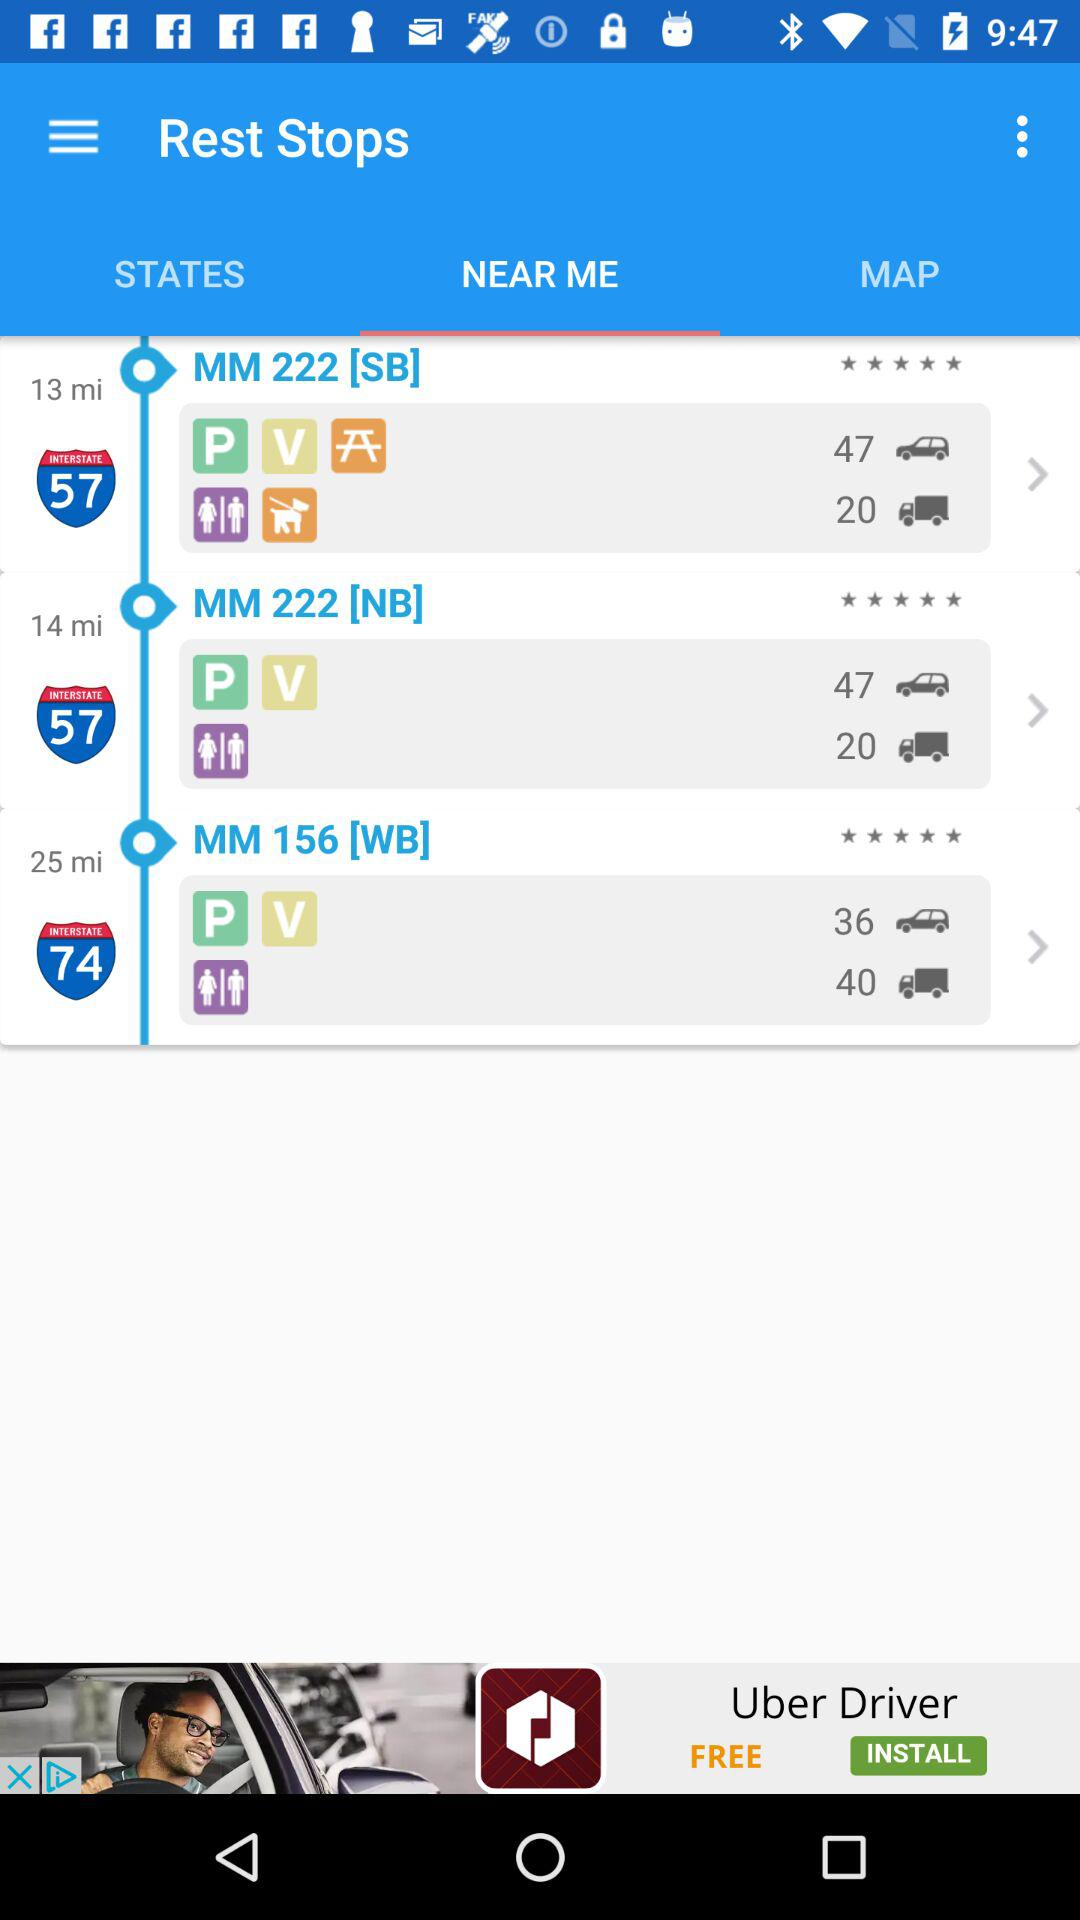How many stars for MM 222[SB]?
When the provided information is insufficient, respond with <no answer>. <no answer> 